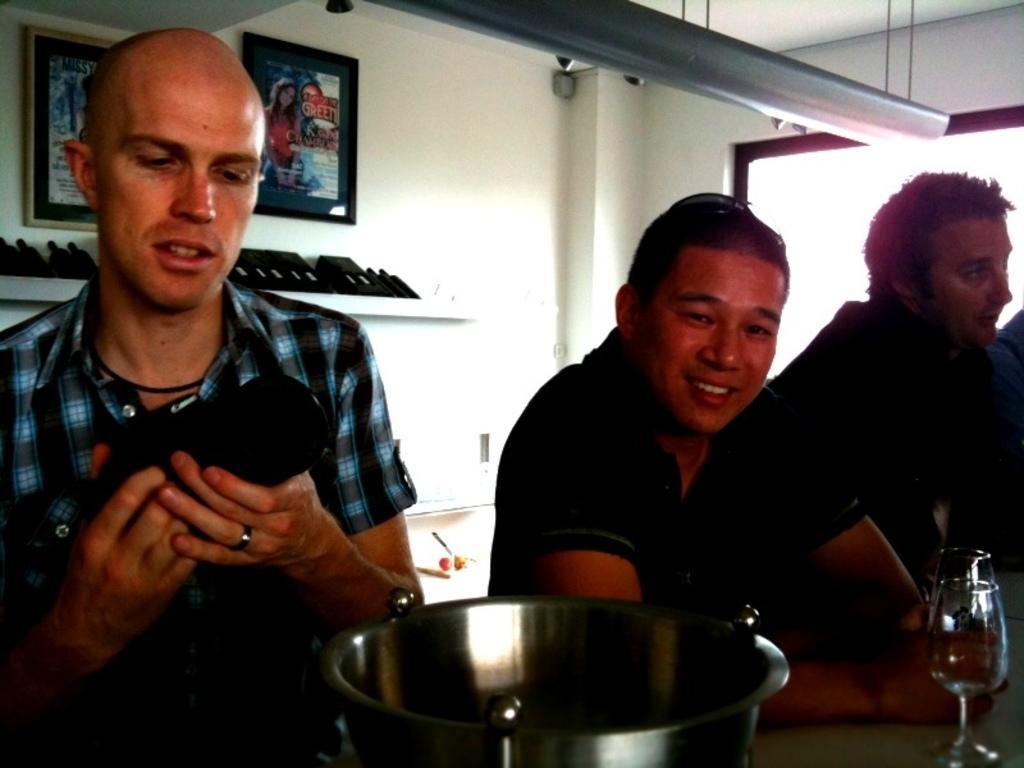In one or two sentences, can you explain what this image depicts? In this picture I can see there are three people standing here and the person on to left is holding a black color object and is looking at it and the person here is smiling and the person standing here at the right is standing is looking at right and there is a utensil and a wine glass on the table and there are few bottles arranged in the backdrop shelf and there is a window on to right. 